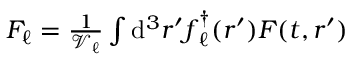Convert formula to latex. <formula><loc_0><loc_0><loc_500><loc_500>\begin{array} { r } { F _ { \ell } = \frac { 1 } { \mathcal { V } _ { \ell } } \int d ^ { 3 } r ^ { \prime } f _ { \ell } ^ { \dagger } ( r ^ { \prime } ) F ( t , r ^ { \prime } ) } \end{array}</formula> 